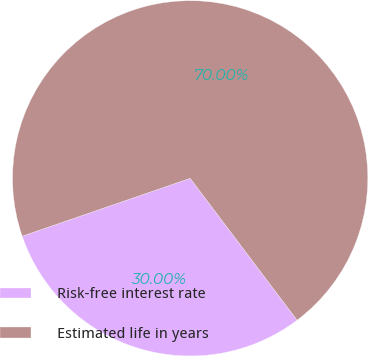Convert chart to OTSL. <chart><loc_0><loc_0><loc_500><loc_500><pie_chart><fcel>Risk-free interest rate<fcel>Estimated life in years<nl><fcel>30.0%<fcel>70.0%<nl></chart> 